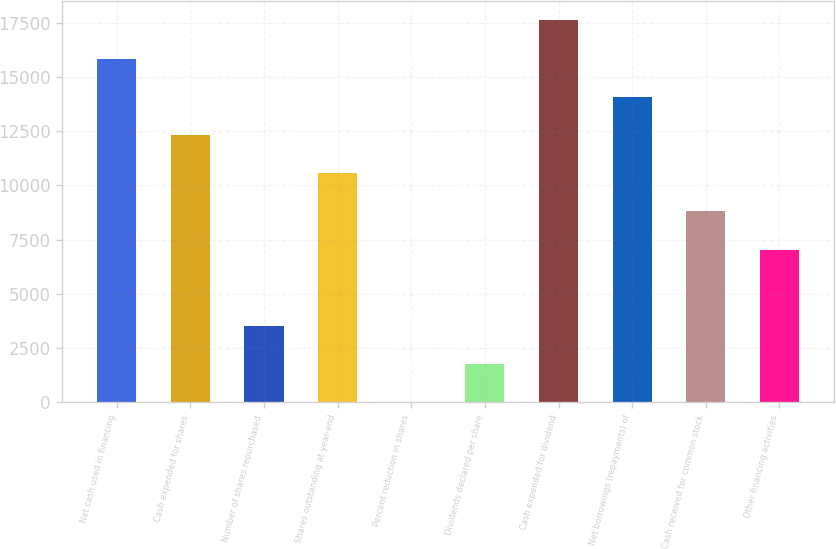Convert chart to OTSL. <chart><loc_0><loc_0><loc_500><loc_500><bar_chart><fcel>Net cash used in financing<fcel>Cash expended for shares<fcel>Number of shares repurchased<fcel>Shares outstanding at year-end<fcel>Percent reduction in shares<fcel>Dividends declared per share<fcel>Cash expended for dividend<fcel>Net borrowings (repayments) of<fcel>Cash received for common stock<fcel>Other financing activities<nl><fcel>15842.8<fcel>12322.4<fcel>3521.4<fcel>10562.2<fcel>1<fcel>1761.2<fcel>17603<fcel>14082.6<fcel>8802<fcel>7041.8<nl></chart> 